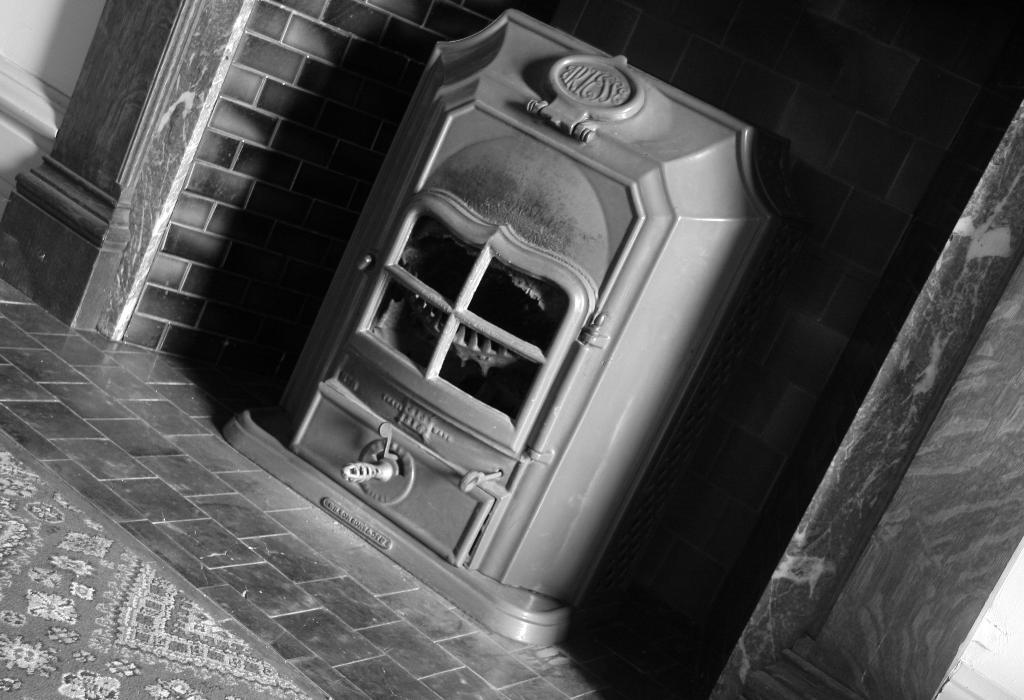What object can be seen in the image? There is a box in the image. What type of structure is visible in the image? There is a wall in the image. What type of floor covering is present in the image? There is a floor mat in the image. What color scheme is used in the image? The image is in black and white. What religious symbol can be seen on the wall in the image? There is no religious symbol present on the wall in the image. What is the desire of the person who placed the box on the floor mat? There is no information about a person's desire in the image, as it only shows a box, a wall, and a floor mat. 